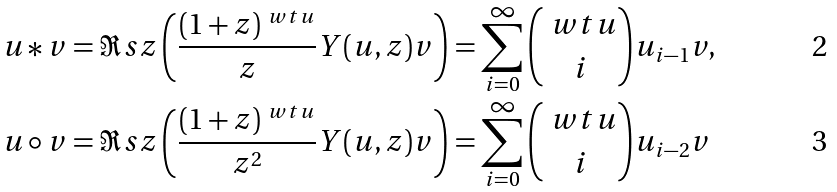Convert formula to latex. <formula><loc_0><loc_0><loc_500><loc_500>u * v & = \Re s { z } \left ( \frac { ( 1 + z ) ^ { \ w t { u } } } { z } Y ( u , z ) v \right ) = \sum _ { i = 0 } ^ { \infty } \binom { \ w t { u } } { i } u _ { i - 1 } v , \\ u \circ v & = \Re s { z } \left ( \frac { ( 1 + z ) ^ { \ w t { u } } } { z ^ { 2 } } Y ( u , z ) v \right ) = \sum _ { i = 0 } ^ { \infty } \binom { \ w t { u } } { i } u _ { i - 2 } v</formula> 